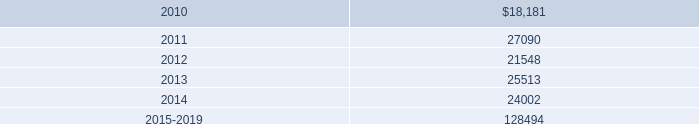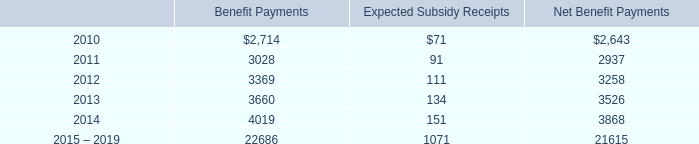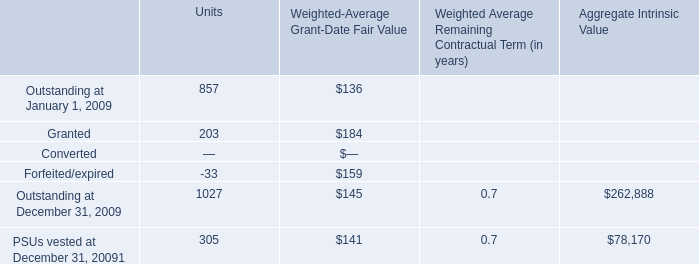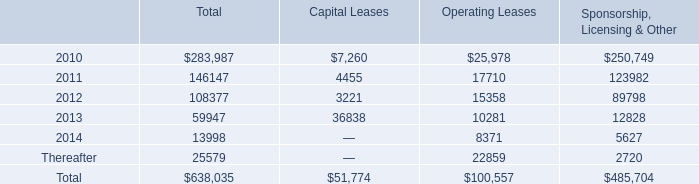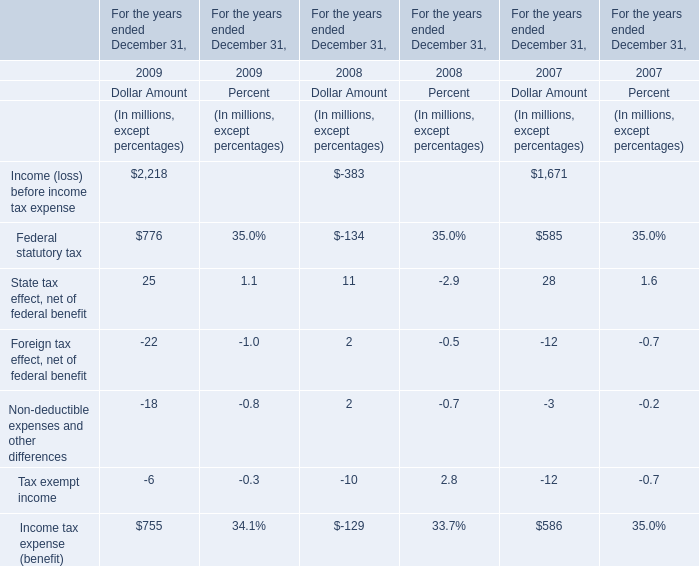what was the ratio of the company 2019s contribution expense related to all of its defined contribution plans for 2009 to 2008 
Computations: (40627 / 35341)
Answer: 1.14957. 